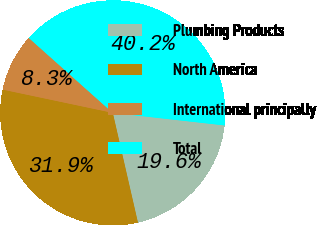<chart> <loc_0><loc_0><loc_500><loc_500><pie_chart><fcel>Plumbing Products<fcel>North America<fcel>International principally<fcel>Total<nl><fcel>19.63%<fcel>31.9%<fcel>8.28%<fcel>40.18%<nl></chart> 